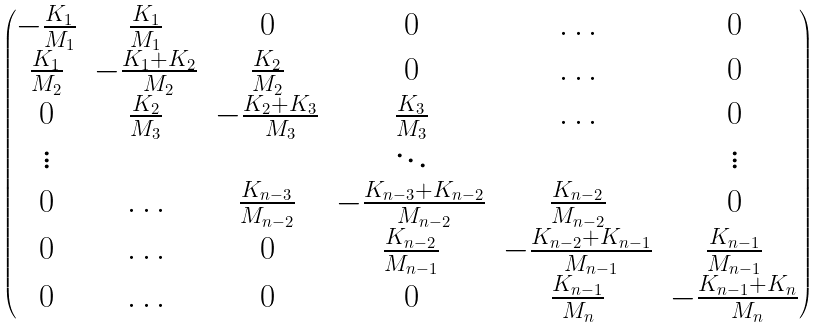Convert formula to latex. <formula><loc_0><loc_0><loc_500><loc_500>\begin{pmatrix} - \frac { K _ { 1 } } { M _ { 1 } } & \frac { K _ { 1 } } { M _ { 1 } } & 0 & 0 & \hdots & 0 \\ \frac { K _ { 1 } } { M _ { 2 } } & - \frac { K _ { 1 } + K _ { 2 } } { M _ { 2 } } & \frac { K _ { 2 } } { M _ { 2 } } & 0 & \hdots & 0 \\ 0 & \frac { K _ { 2 } } { M _ { 3 } } & - \frac { K _ { 2 } + K _ { 3 } } { M _ { 3 } } & \frac { K _ { 3 } } { M _ { 3 } } & \hdots & 0 \\ \vdots & \ & \ & \ddots & \ & \vdots \\ 0 & \hdots & \frac { K _ { n - 3 } } { M _ { n - 2 } } & - \frac { K _ { n - 3 } + K _ { n - 2 } } { M _ { n - 2 } } & \frac { K _ { n - 2 } } { M _ { n - 2 } } & 0 \\ 0 & \hdots & 0 & \frac { K _ { n - 2 } } { M _ { n - 1 } } & - \frac { K _ { n - 2 } + K _ { n - 1 } } { M _ { n - 1 } } & \frac { K _ { n - 1 } } { M _ { n - 1 } } \\ 0 & \hdots & 0 & 0 & \frac { K _ { n - 1 } } { M _ { n } } & - \frac { K _ { n - 1 } + K _ { n } } { M _ { n } } \\ \end{pmatrix}</formula> 